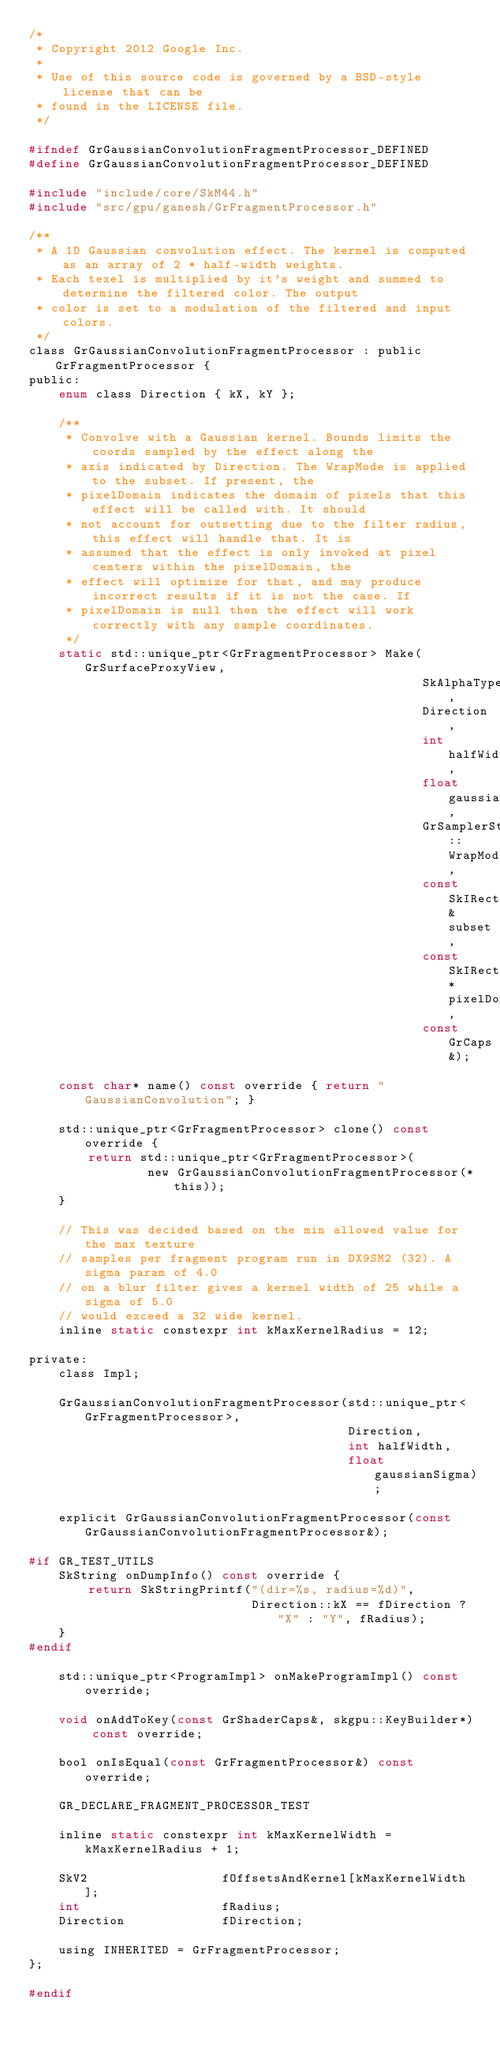Convert code to text. <code><loc_0><loc_0><loc_500><loc_500><_C_>/*
 * Copyright 2012 Google Inc.
 *
 * Use of this source code is governed by a BSD-style license that can be
 * found in the LICENSE file.
 */

#ifndef GrGaussianConvolutionFragmentProcessor_DEFINED
#define GrGaussianConvolutionFragmentProcessor_DEFINED

#include "include/core/SkM44.h"
#include "src/gpu/ganesh/GrFragmentProcessor.h"

/**
 * A 1D Gaussian convolution effect. The kernel is computed as an array of 2 * half-width weights.
 * Each texel is multiplied by it's weight and summed to determine the filtered color. The output
 * color is set to a modulation of the filtered and input colors.
 */
class GrGaussianConvolutionFragmentProcessor : public GrFragmentProcessor {
public:
    enum class Direction { kX, kY };

    /**
     * Convolve with a Gaussian kernel. Bounds limits the coords sampled by the effect along the
     * axis indicated by Direction. The WrapMode is applied to the subset. If present, the
     * pixelDomain indicates the domain of pixels that this effect will be called with. It should
     * not account for outsetting due to the filter radius, this effect will handle that. It is
     * assumed that the effect is only invoked at pixel centers within the pixelDomain, the
     * effect will optimize for that, and may produce incorrect results if it is not the case. If
     * pixelDomain is null then the effect will work correctly with any sample coordinates.
     */
    static std::unique_ptr<GrFragmentProcessor> Make(GrSurfaceProxyView,
                                                     SkAlphaType,
                                                     Direction,
                                                     int halfWidth,
                                                     float gaussianSigma,
                                                     GrSamplerState::WrapMode,
                                                     const SkIRect& subset,
                                                     const SkIRect* pixelDomain,
                                                     const GrCaps&);

    const char* name() const override { return "GaussianConvolution"; }

    std::unique_ptr<GrFragmentProcessor> clone() const override {
        return std::unique_ptr<GrFragmentProcessor>(
                new GrGaussianConvolutionFragmentProcessor(*this));
    }

    // This was decided based on the min allowed value for the max texture
    // samples per fragment program run in DX9SM2 (32). A sigma param of 4.0
    // on a blur filter gives a kernel width of 25 while a sigma of 5.0
    // would exceed a 32 wide kernel.
    inline static constexpr int kMaxKernelRadius = 12;

private:
    class Impl;

    GrGaussianConvolutionFragmentProcessor(std::unique_ptr<GrFragmentProcessor>,
                                           Direction,
                                           int halfWidth,
                                           float gaussianSigma);

    explicit GrGaussianConvolutionFragmentProcessor(const GrGaussianConvolutionFragmentProcessor&);

#if GR_TEST_UTILS
    SkString onDumpInfo() const override {
        return SkStringPrintf("(dir=%s, radius=%d)",
                              Direction::kX == fDirection ? "X" : "Y", fRadius);
    }
#endif

    std::unique_ptr<ProgramImpl> onMakeProgramImpl() const override;

    void onAddToKey(const GrShaderCaps&, skgpu::KeyBuilder*) const override;

    bool onIsEqual(const GrFragmentProcessor&) const override;

    GR_DECLARE_FRAGMENT_PROCESSOR_TEST

    inline static constexpr int kMaxKernelWidth = kMaxKernelRadius + 1;

    SkV2                  fOffsetsAndKernel[kMaxKernelWidth];
    int                   fRadius;
    Direction             fDirection;

    using INHERITED = GrFragmentProcessor;
};

#endif
</code> 